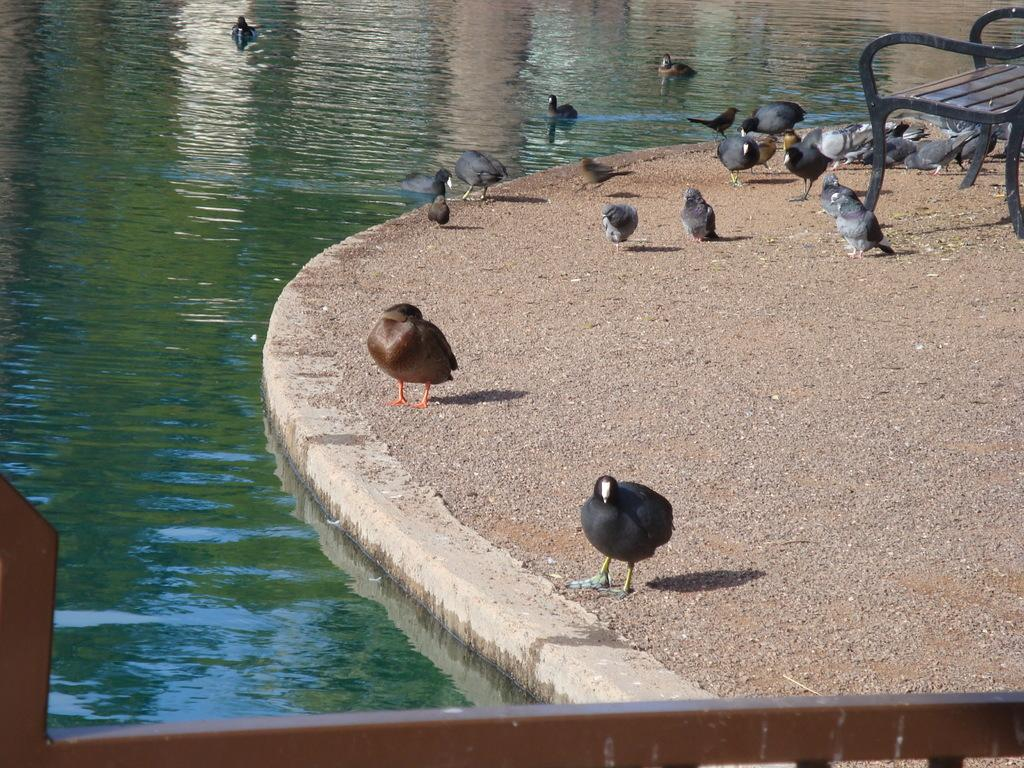What type of animals can be seen in the image? There is a group of birds in the image. What is located on the ground in the image? There is a bench on the ground in the image. What material is the pole in the image made of? The pole in the image is made of metal. Where are some of the birds located in the image? There are birds in a water body in the image. What type of calendar is hanging on the back of the bench in the image? There is no calendar present in the image, and the back of the bench is not visible. 